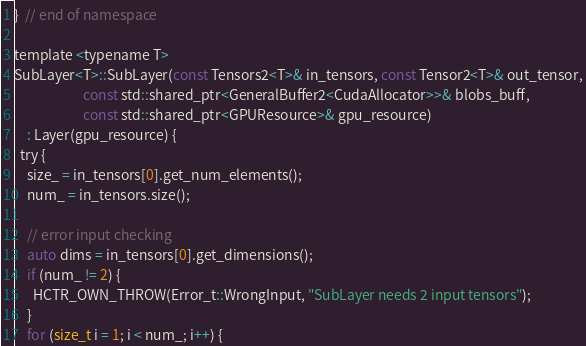<code> <loc_0><loc_0><loc_500><loc_500><_Cuda_>}  // end of namespace

template <typename T>
SubLayer<T>::SubLayer(const Tensors2<T>& in_tensors, const Tensor2<T>& out_tensor,
                      const std::shared_ptr<GeneralBuffer2<CudaAllocator>>& blobs_buff,
                      const std::shared_ptr<GPUResource>& gpu_resource)
    : Layer(gpu_resource) {
  try {
    size_ = in_tensors[0].get_num_elements();
    num_ = in_tensors.size();

    // error input checking
    auto dims = in_tensors[0].get_dimensions();
    if (num_ != 2) {
      HCTR_OWN_THROW(Error_t::WrongInput, "SubLayer needs 2 input tensors");
    }
    for (size_t i = 1; i < num_; i++) {</code> 